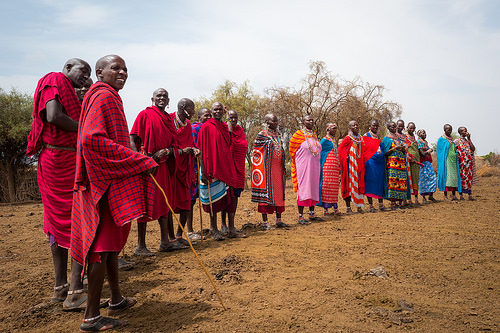<image>
Is the person one on the person two? No. The person one is not positioned on the person two. They may be near each other, but the person one is not supported by or resting on top of the person two. Is there a man behind the ground? No. The man is not behind the ground. From this viewpoint, the man appears to be positioned elsewhere in the scene. 